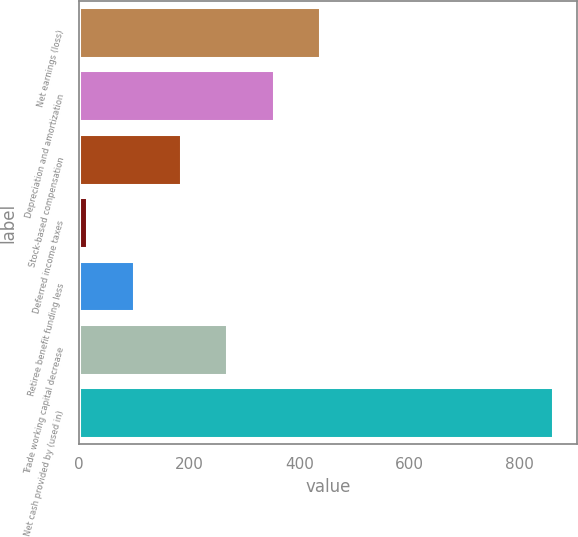Convert chart. <chart><loc_0><loc_0><loc_500><loc_500><bar_chart><fcel>Net earnings (loss)<fcel>Depreciation and amortization<fcel>Stock-based compensation<fcel>Deferred income taxes<fcel>Retiree benefit funding less<fcel>Trade working capital decrease<fcel>Net cash provided by (used in)<nl><fcel>438<fcel>353.4<fcel>184.2<fcel>15<fcel>99.6<fcel>268.8<fcel>861<nl></chart> 